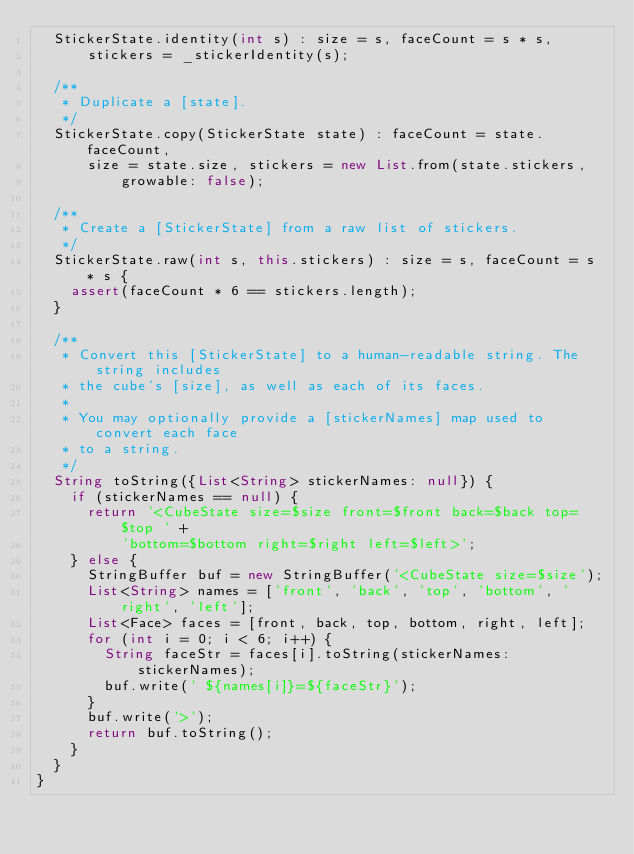<code> <loc_0><loc_0><loc_500><loc_500><_Dart_>  StickerState.identity(int s) : size = s, faceCount = s * s,
      stickers = _stickerIdentity(s);
  
  /**
   * Duplicate a [state].
   */
  StickerState.copy(StickerState state) : faceCount = state.faceCount,
      size = state.size, stickers = new List.from(state.stickers,
          growable: false);
  
  /**
   * Create a [StickerState] from a raw list of stickers.
   */
  StickerState.raw(int s, this.stickers) : size = s, faceCount = s * s {
    assert(faceCount * 6 == stickers.length);
  }
  
  /**
   * Convert this [StickerState] to a human-readable string. The string includes
   * the cube's [size], as well as each of its faces.
   * 
   * You may optionally provide a [stickerNames] map used to convert each face
   * to a string.
   */
  String toString({List<String> stickerNames: null}) {
    if (stickerNames == null) {
      return '<CubeState size=$size front=$front back=$back top=$top ' +
          'bottom=$bottom right=$right left=$left>';
    } else {
      StringBuffer buf = new StringBuffer('<CubeState size=$size');
      List<String> names = ['front', 'back', 'top', 'bottom', 'right', 'left'];
      List<Face> faces = [front, back, top, bottom, right, left];
      for (int i = 0; i < 6; i++) {
        String faceStr = faces[i].toString(stickerNames: stickerNames);
        buf.write(' ${names[i]}=${faceStr}');
      }
      buf.write('>');
      return buf.toString();
    }
  }
}
</code> 